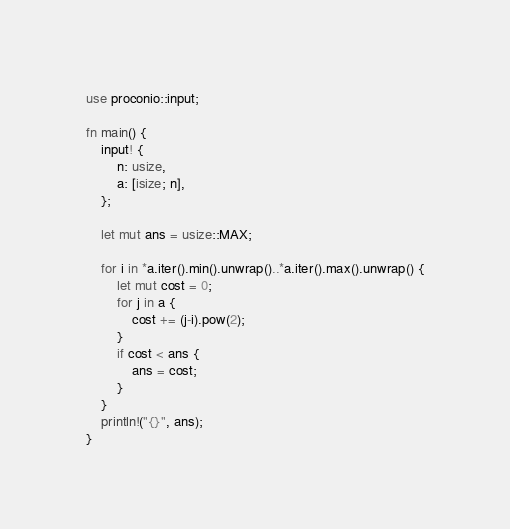Convert code to text. <code><loc_0><loc_0><loc_500><loc_500><_Rust_>use proconio::input;

fn main() {
    input! {
        n: usize,
        a: [isize; n],
    };

    let mut ans = usize::MAX;

    for i in *a.iter().min().unwrap()..*a.iter().max().unwrap() {
        let mut cost = 0;
        for j in a {
            cost += (j-i).pow(2);
        }
        if cost < ans {
            ans = cost;
        }
    }
    println!("{}", ans);
}
</code> 